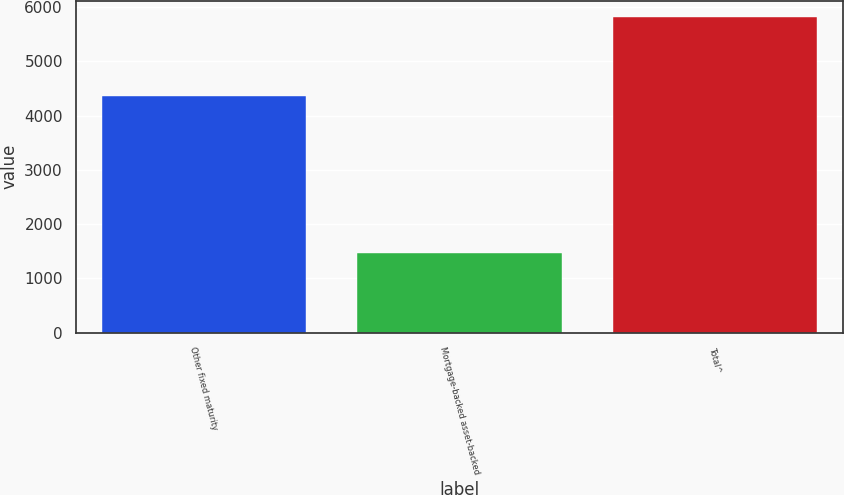Convert chart to OTSL. <chart><loc_0><loc_0><loc_500><loc_500><bar_chart><fcel>Other fixed maturity<fcel>Mortgage-backed asset-backed<fcel>Total^<nl><fcel>4354<fcel>1470<fcel>5824<nl></chart> 